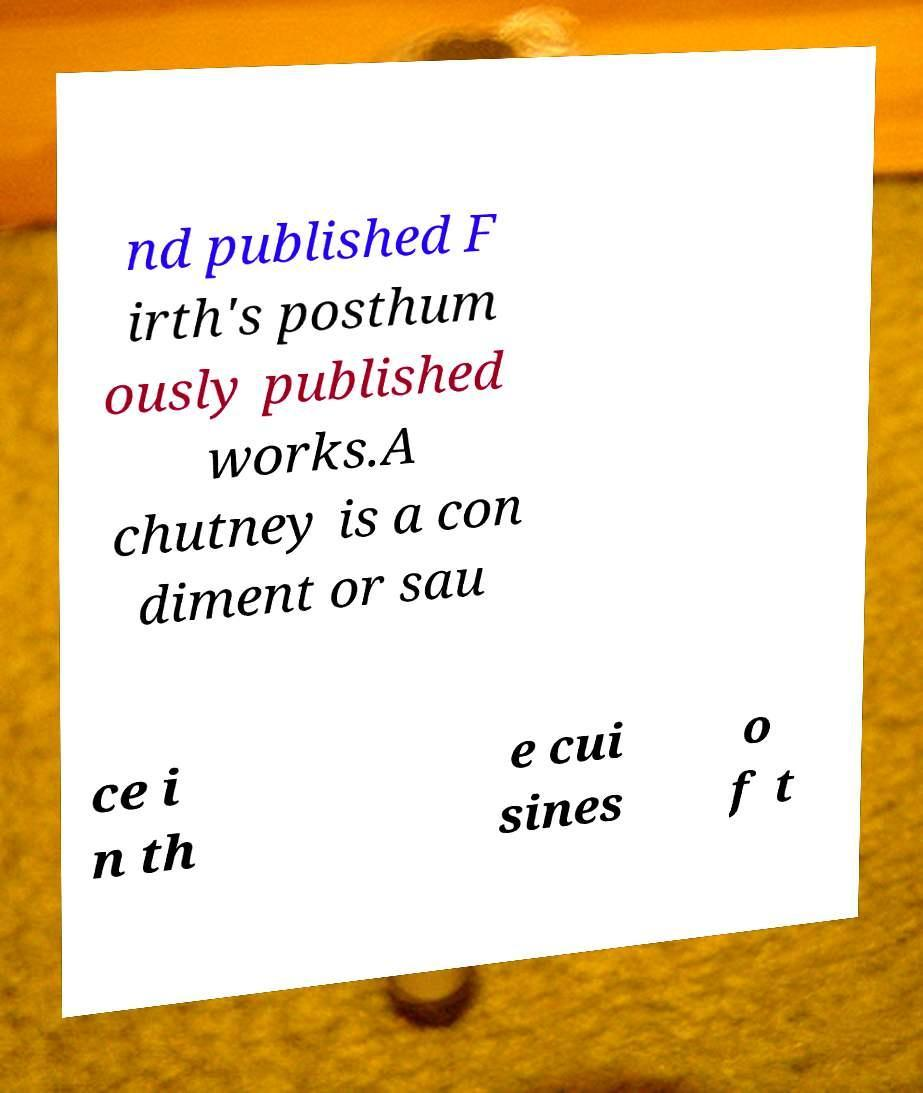Please read and relay the text visible in this image. What does it say? nd published F irth's posthum ously published works.A chutney is a con diment or sau ce i n th e cui sines o f t 